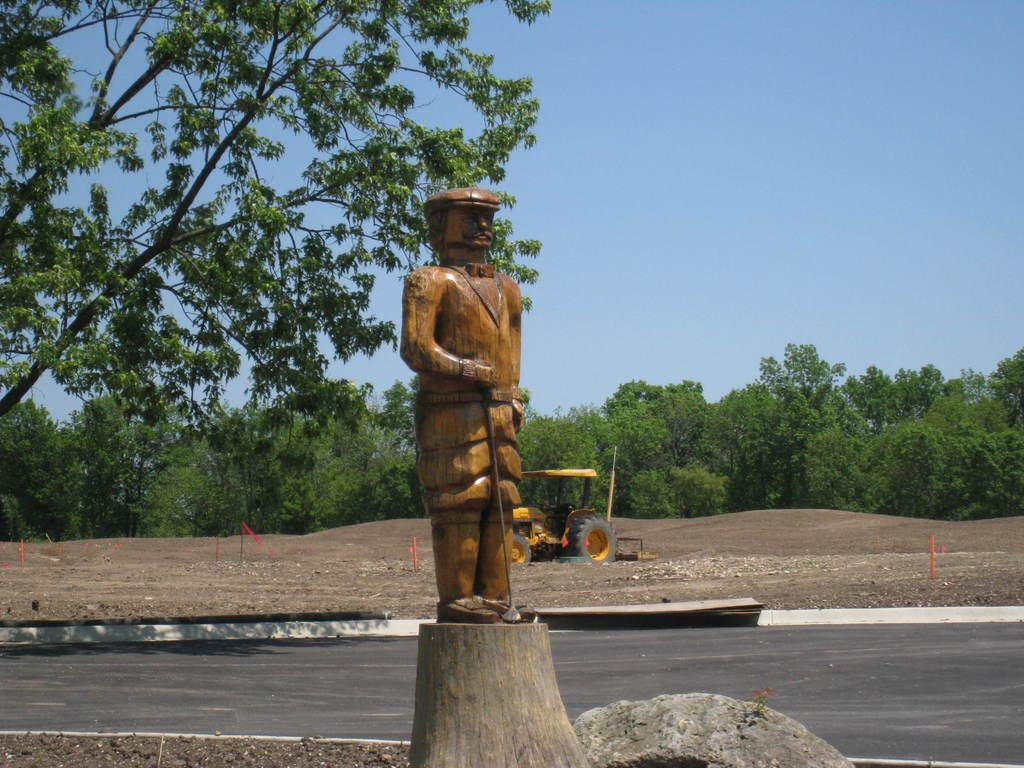What is the main subject in the center of the image? There is a statue in the center of the image. What can be seen in the background of the image? There is a vehicle and trees in the background of the image. What is visible in the sky in the image? The sky is visible in the background of the image. What type of surface is at the bottom of the image? There is a road at the bottom of the image. What type of mitten is being used to harvest the grain in the image? There is no mitten or grain present in the image; it features a statue, a vehicle, trees, and a road. 